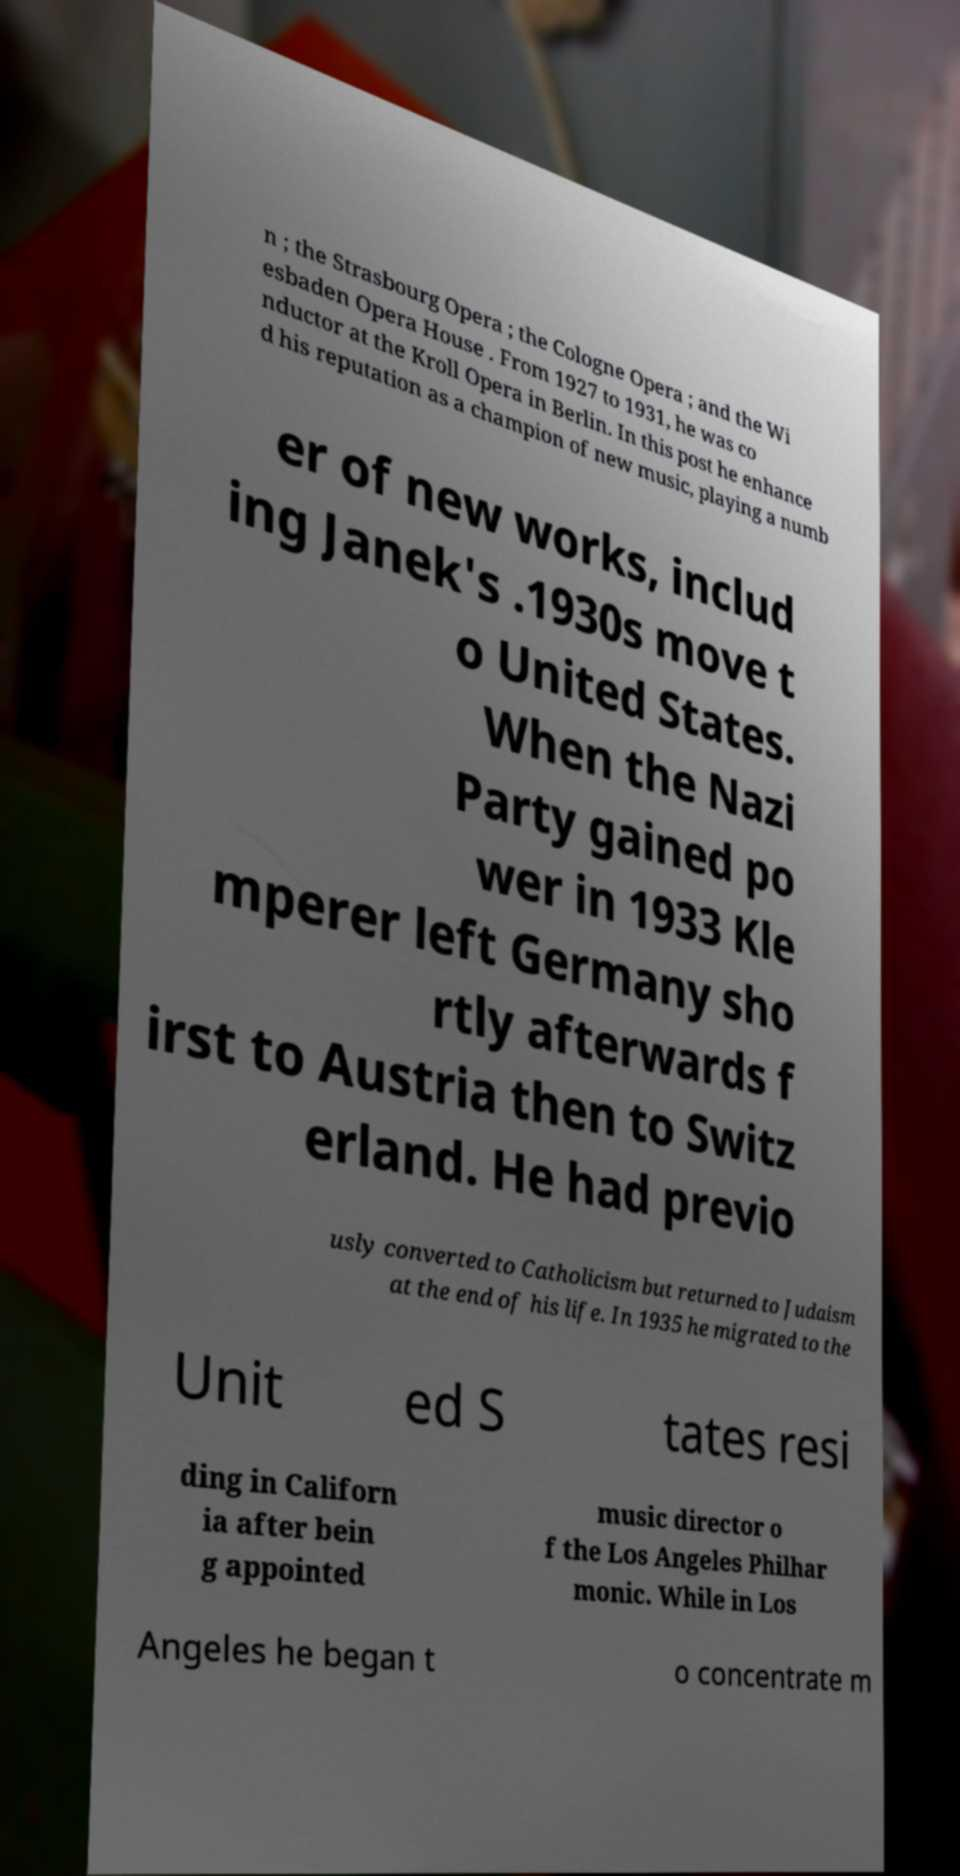There's text embedded in this image that I need extracted. Can you transcribe it verbatim? n ; the Strasbourg Opera ; the Cologne Opera ; and the Wi esbaden Opera House . From 1927 to 1931, he was co nductor at the Kroll Opera in Berlin. In this post he enhance d his reputation as a champion of new music, playing a numb er of new works, includ ing Janek's .1930s move t o United States. When the Nazi Party gained po wer in 1933 Kle mperer left Germany sho rtly afterwards f irst to Austria then to Switz erland. He had previo usly converted to Catholicism but returned to Judaism at the end of his life. In 1935 he migrated to the Unit ed S tates resi ding in Californ ia after bein g appointed music director o f the Los Angeles Philhar monic. While in Los Angeles he began t o concentrate m 